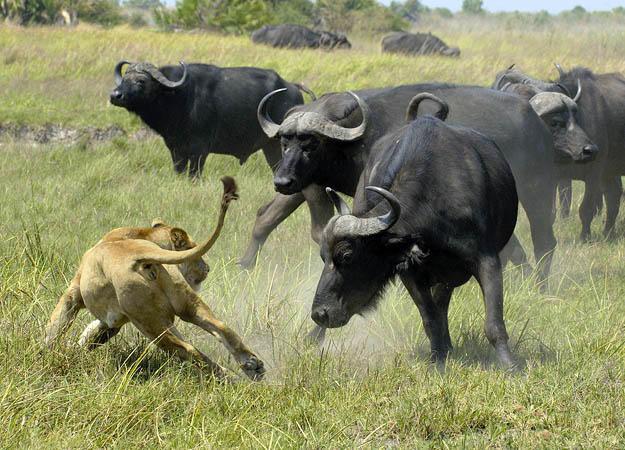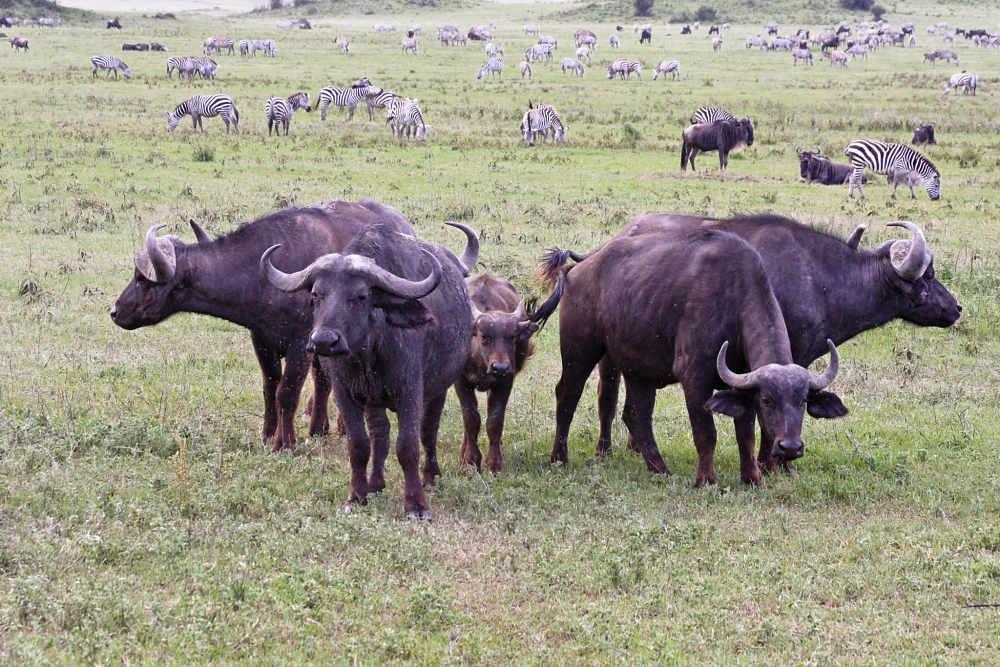The first image is the image on the left, the second image is the image on the right. Examine the images to the left and right. Is the description "There is at least one white bird in the right image." accurate? Answer yes or no. No. The first image is the image on the left, the second image is the image on the right. For the images shown, is this caption "All water buffalo are standing, and no water buffalo are in a scene with other types of mammals." true? Answer yes or no. No. 